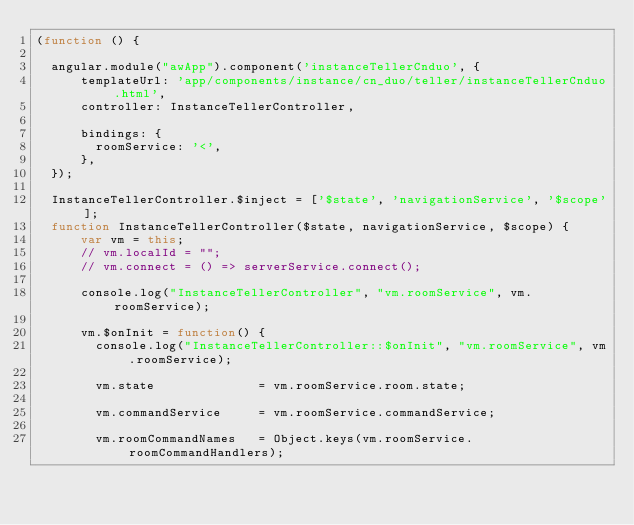Convert code to text. <code><loc_0><loc_0><loc_500><loc_500><_JavaScript_>(function () {

  angular.module("awApp").component('instanceTellerCnduo', {
      templateUrl: 'app/components/instance/cn_duo/teller/instanceTellerCnduo.html',
      controller: InstanceTellerController,

      bindings: {
        roomService: '<',
      },
  });

  InstanceTellerController.$inject = ['$state', 'navigationService', '$scope'];
  function InstanceTellerController($state, navigationService, $scope) {
      var vm = this;
      // vm.localId = "";
      // vm.connect = () => serverService.connect();

      console.log("InstanceTellerController", "vm.roomService", vm.roomService);

      vm.$onInit = function() {
        console.log("InstanceTellerController::$onInit", "vm.roomService", vm.roomService);

        vm.state              = vm.roomService.room.state;

        vm.commandService     = vm.roomService.commandService;

        vm.roomCommandNames   = Object.keys(vm.roomService.roomCommandHandlers);</code> 